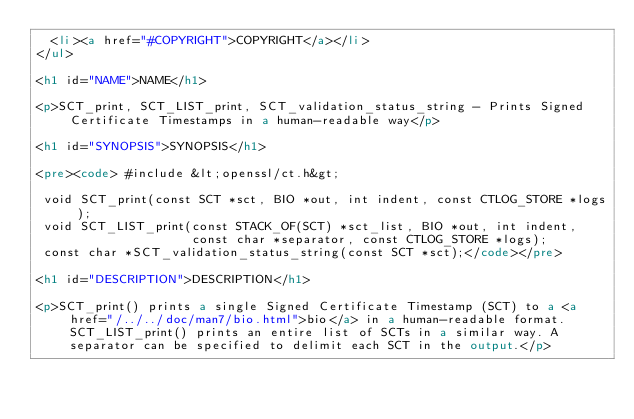Convert code to text. <code><loc_0><loc_0><loc_500><loc_500><_HTML_>  <li><a href="#COPYRIGHT">COPYRIGHT</a></li>
</ul>

<h1 id="NAME">NAME</h1>

<p>SCT_print, SCT_LIST_print, SCT_validation_status_string - Prints Signed Certificate Timestamps in a human-readable way</p>

<h1 id="SYNOPSIS">SYNOPSIS</h1>

<pre><code> #include &lt;openssl/ct.h&gt;

 void SCT_print(const SCT *sct, BIO *out, int indent, const CTLOG_STORE *logs);
 void SCT_LIST_print(const STACK_OF(SCT) *sct_list, BIO *out, int indent,
                     const char *separator, const CTLOG_STORE *logs);
 const char *SCT_validation_status_string(const SCT *sct);</code></pre>

<h1 id="DESCRIPTION">DESCRIPTION</h1>

<p>SCT_print() prints a single Signed Certificate Timestamp (SCT) to a <a href="/../../doc/man7/bio.html">bio</a> in a human-readable format. SCT_LIST_print() prints an entire list of SCTs in a similar way. A separator can be specified to delimit each SCT in the output.</p>
</code> 